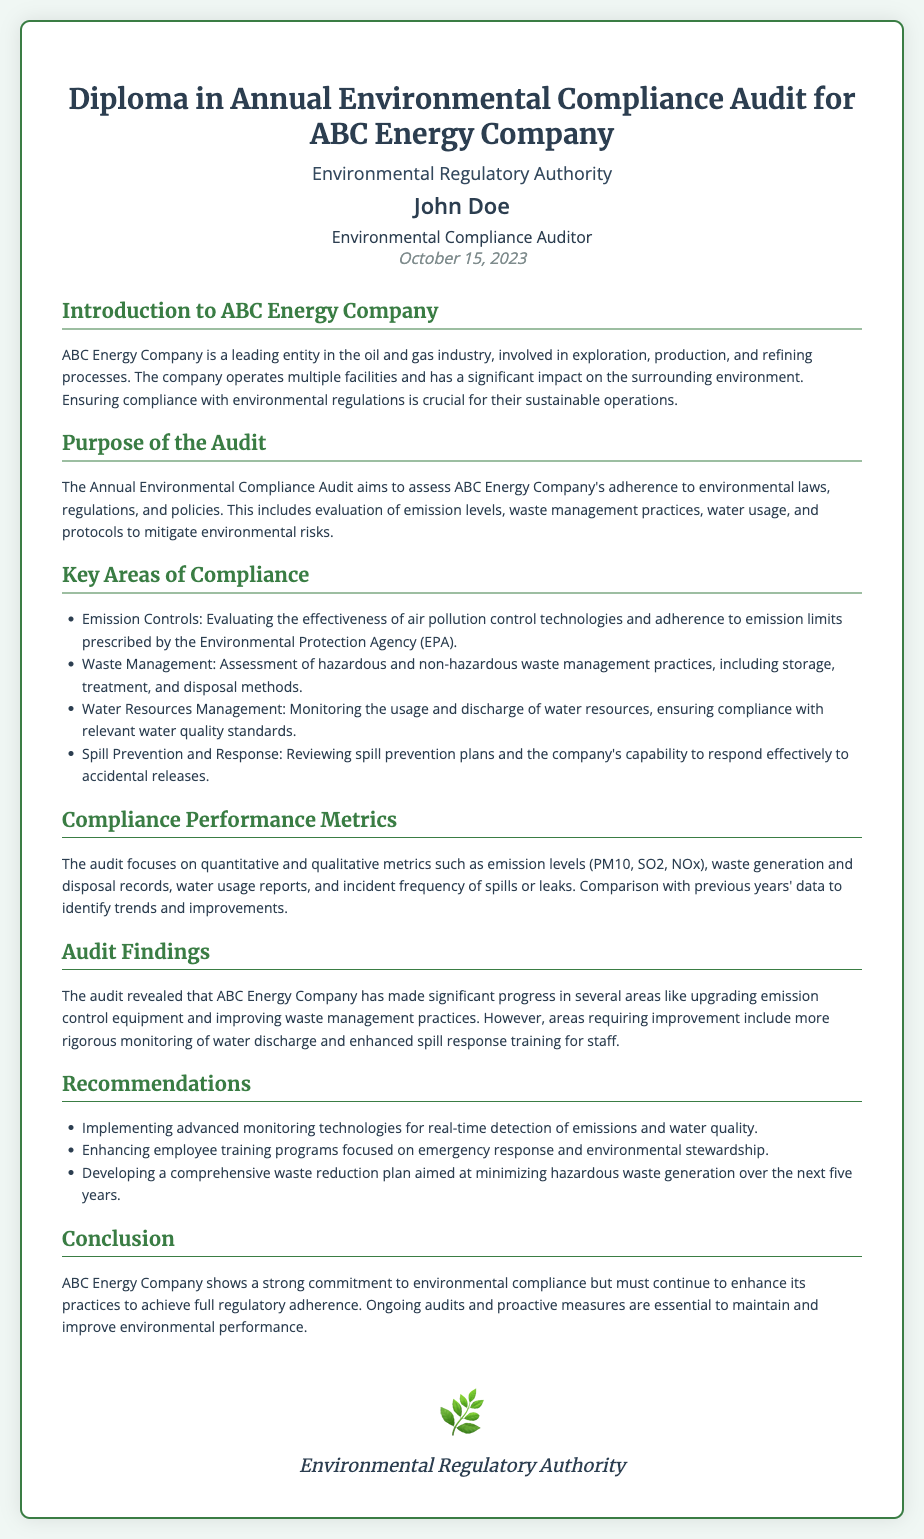What is the title of the diploma? The title of the diploma is the primary heading within the document, which states the name and focus of the award.
Answer: Diploma in Annual Environmental Compliance Audit for ABC Energy Company Who is the recipient of the diploma? The recipient is specified in the document as the individual who has been awarded the diploma.
Answer: John Doe What is the date of the diploma? The date is indicated prominently in the document, reflecting when it was awarded.
Answer: October 15, 2023 What organization issued the diploma? The organization responsible for issuing the diploma is noted within the header section of the document.
Answer: Environmental Regulatory Authority What are the key areas of compliance assessed in the audit? The key areas are listed in a bulleted format in the document and reflect the focus of compliance evaluation.
Answer: Emission Controls, Waste Management, Water Resources Management, Spill Prevention and Response What was a significant finding from the audit? Significant audit findings pertain to ABC Energy Company's progress and areas needing improvement, reflected in the document’s audit findings section.
Answer: More rigorous monitoring of water discharge What is one of the recommendations made in the audit? Recommendations are also recorded in bulleted format, providing insights on improvements needed for compliance.
Answer: Implementing advanced monitoring technologies How does the audit impact ABC Energy Company's commitment to regulations? The conclusion summarizes the overall impact of the audit findings on the company's commitment to adherence to environmental laws.
Answer: Strong commitment 